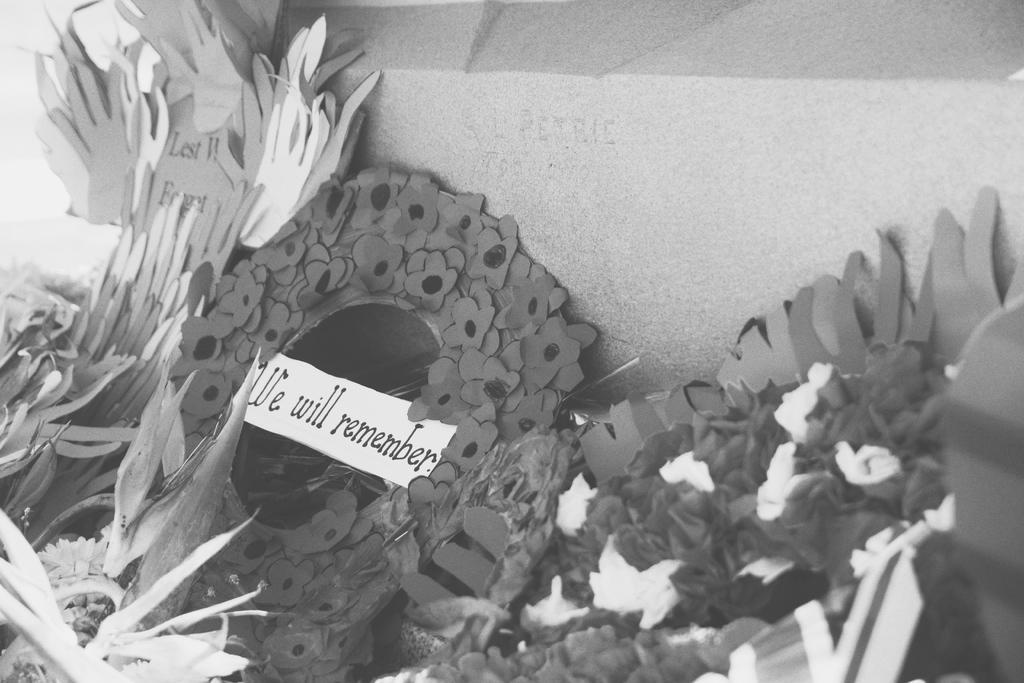Can you describe this image briefly? In the foreground of this image, there are few paper flowers and a paper with text. At the top, it seems like a stone. 